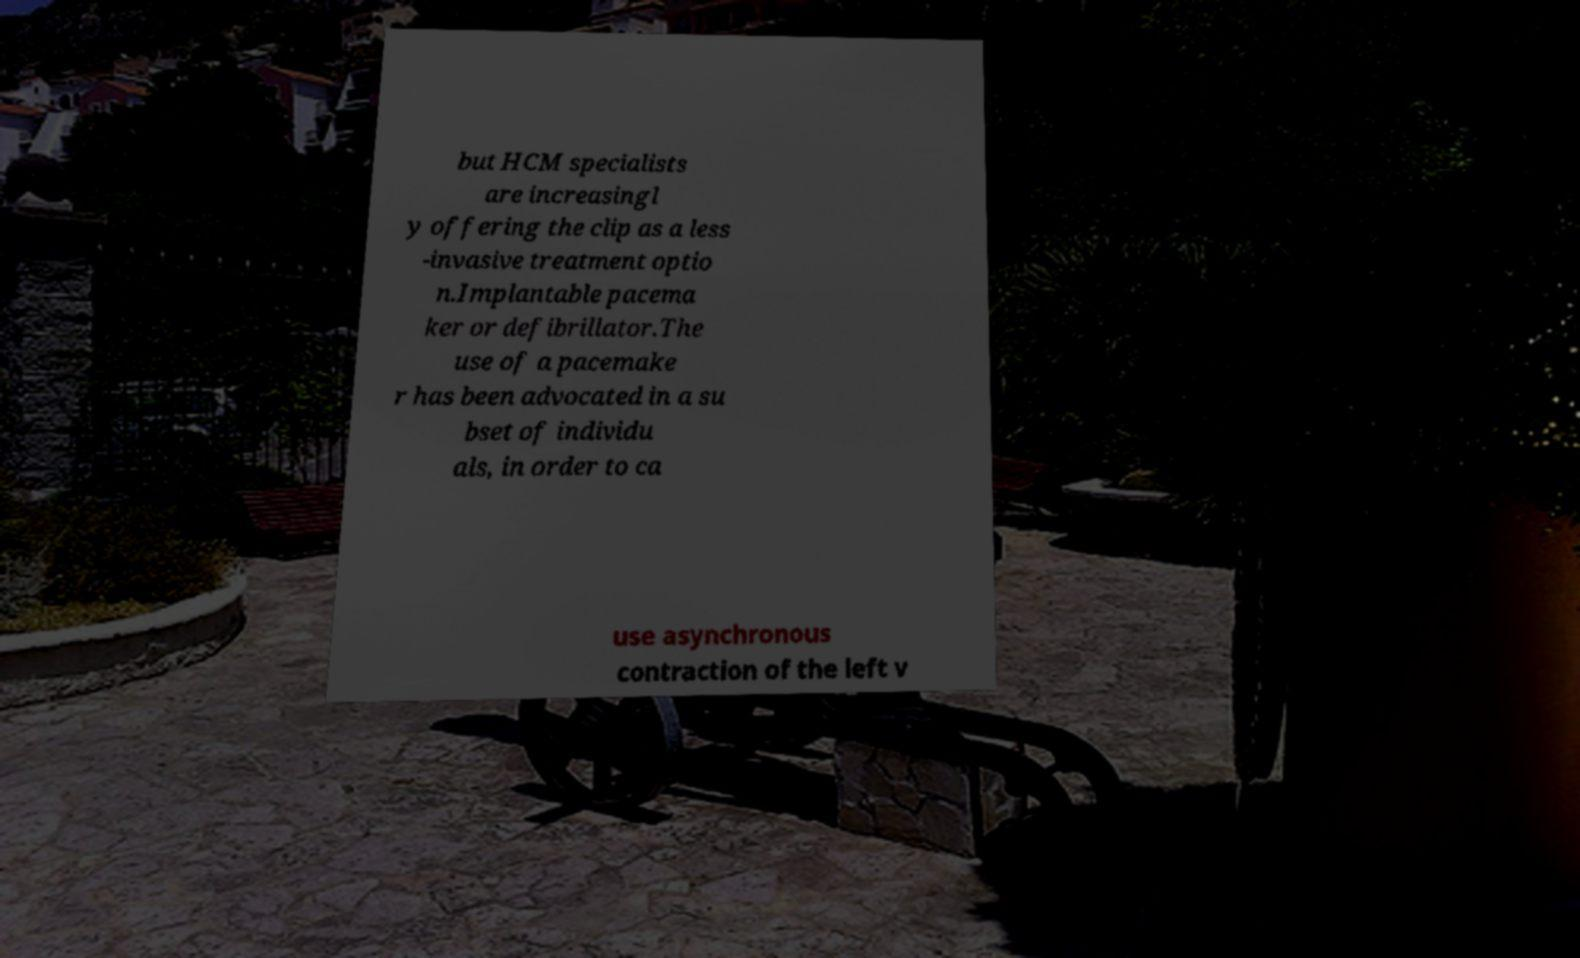What messages or text are displayed in this image? I need them in a readable, typed format. but HCM specialists are increasingl y offering the clip as a less -invasive treatment optio n.Implantable pacema ker or defibrillator.The use of a pacemake r has been advocated in a su bset of individu als, in order to ca use asynchronous contraction of the left v 